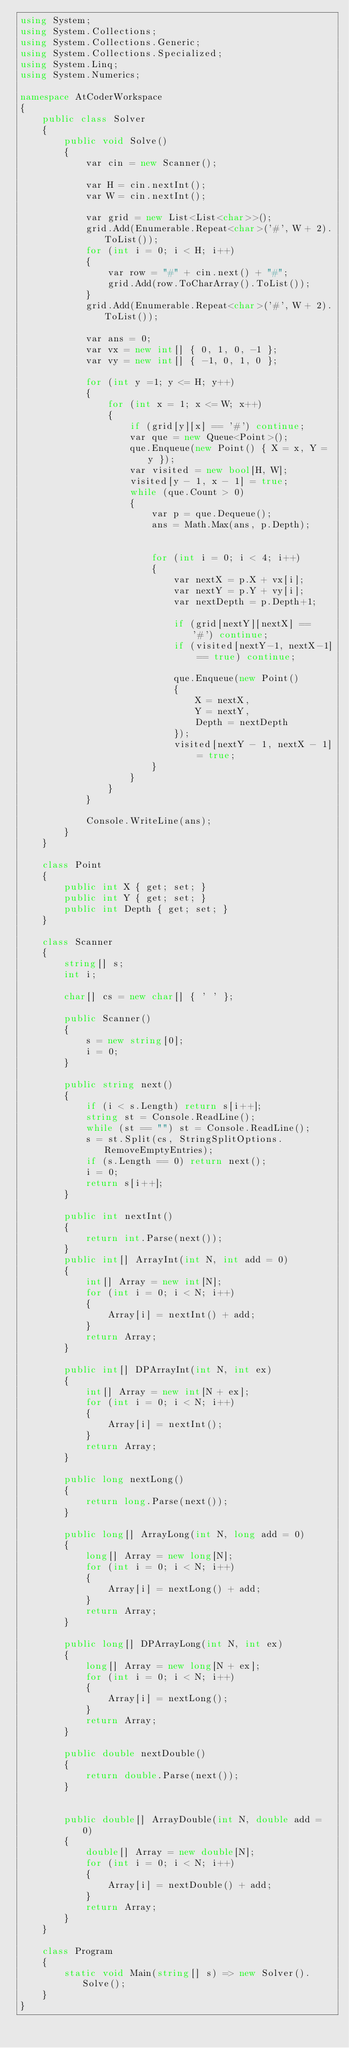<code> <loc_0><loc_0><loc_500><loc_500><_C#_>using System;
using System.Collections;
using System.Collections.Generic;
using System.Collections.Specialized;
using System.Linq;
using System.Numerics;

namespace AtCoderWorkspace
{
    public class Solver
    {
        public void Solve()
        {
            var cin = new Scanner();
            
            var H = cin.nextInt();
            var W = cin.nextInt();

            var grid = new List<List<char>>();
            grid.Add(Enumerable.Repeat<char>('#', W + 2).ToList());
            for (int i = 0; i < H; i++)
            {
                var row = "#" + cin.next() + "#";
                grid.Add(row.ToCharArray().ToList());
            }
            grid.Add(Enumerable.Repeat<char>('#', W + 2).ToList());
                       
            var ans = 0;
            var vx = new int[] { 0, 1, 0, -1 };
            var vy = new int[] { -1, 0, 1, 0 };
            
            for (int y =1; y <= H; y++)
            {
                for (int x = 1; x <= W; x++)
                {
                    if (grid[y][x] == '#') continue;
                    var que = new Queue<Point>();
                    que.Enqueue(new Point() { X = x, Y = y });
                    var visited = new bool[H, W];
                    visited[y - 1, x - 1] = true;
                    while (que.Count > 0)
                    {
                        var p = que.Dequeue();
                        ans = Math.Max(ans, p.Depth);
                        

                        for (int i = 0; i < 4; i++)
                        {
                            var nextX = p.X + vx[i];
                            var nextY = p.Y + vy[i];
                            var nextDepth = p.Depth+1;

                            if (grid[nextY][nextX] == '#') continue;
                            if (visited[nextY-1, nextX-1] == true) continue;

                            que.Enqueue(new Point()
                            {
                                X = nextX,
                                Y = nextY,
                                Depth = nextDepth
                            });
                            visited[nextY - 1, nextX - 1] = true;
                        }                        
                    }
                }
            }

            Console.WriteLine(ans);
        }
    }

    class Point
    {
        public int X { get; set; }
        public int Y { get; set; }
        public int Depth { get; set; }
    }

    class Scanner
    {
        string[] s;
        int i;

        char[] cs = new char[] { ' ' };

        public Scanner()
        {
            s = new string[0];
            i = 0;
        }

        public string next()
        {
            if (i < s.Length) return s[i++];
            string st = Console.ReadLine();
            while (st == "") st = Console.ReadLine();
            s = st.Split(cs, StringSplitOptions.RemoveEmptyEntries);
            if (s.Length == 0) return next();
            i = 0;
            return s[i++];
        }

        public int nextInt()
        {
            return int.Parse(next());
        }
        public int[] ArrayInt(int N, int add = 0)
        {
            int[] Array = new int[N];
            for (int i = 0; i < N; i++)
            {
                Array[i] = nextInt() + add;
            }
            return Array;
        }

        public int[] DPArrayInt(int N, int ex)
        {
            int[] Array = new int[N + ex];
            for (int i = 0; i < N; i++)
            {
                Array[i] = nextInt();
            }
            return Array;
        }

        public long nextLong()
        {
            return long.Parse(next());
        }

        public long[] ArrayLong(int N, long add = 0)
        {
            long[] Array = new long[N];
            for (int i = 0; i < N; i++)
            {
                Array[i] = nextLong() + add;
            }
            return Array;
        }

        public long[] DPArrayLong(int N, int ex)
        {
            long[] Array = new long[N + ex];
            for (int i = 0; i < N; i++)
            {
                Array[i] = nextLong();
            }
            return Array;
        }

        public double nextDouble()
        {
            return double.Parse(next());
        }


        public double[] ArrayDouble(int N, double add = 0)
        {
            double[] Array = new double[N];
            for (int i = 0; i < N; i++)
            {
                Array[i] = nextDouble() + add;
            }
            return Array;
        }
    }

    class Program
    {
        static void Main(string[] s) => new Solver().Solve();
    }
}
</code> 